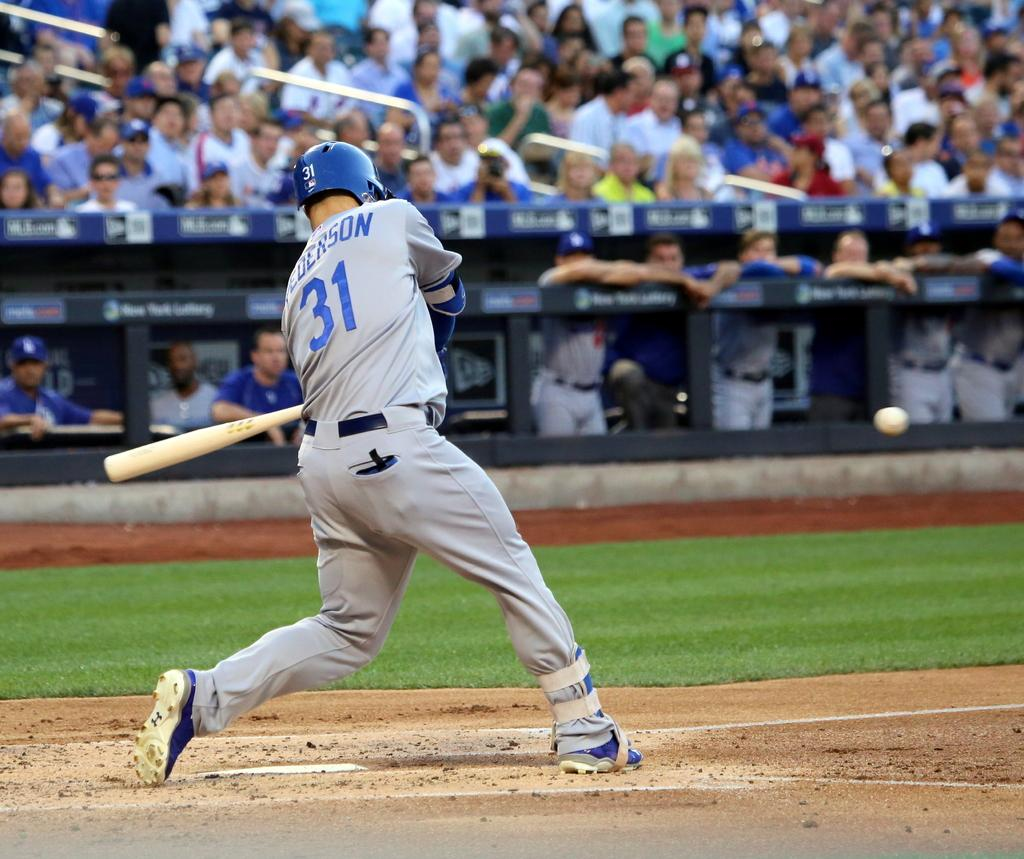<image>
Relay a brief, clear account of the picture shown. player #31 in grey swings the bat in front of crowd 